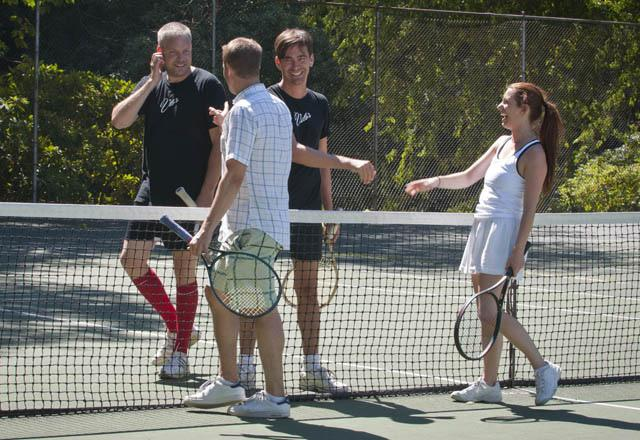What is the relationship of the man wearing white checker shirt to the woman wearing white skirt in this situation? Please explain your reasoning. teammate. The man in the checker shirt and the woman in white are both on the same team. 